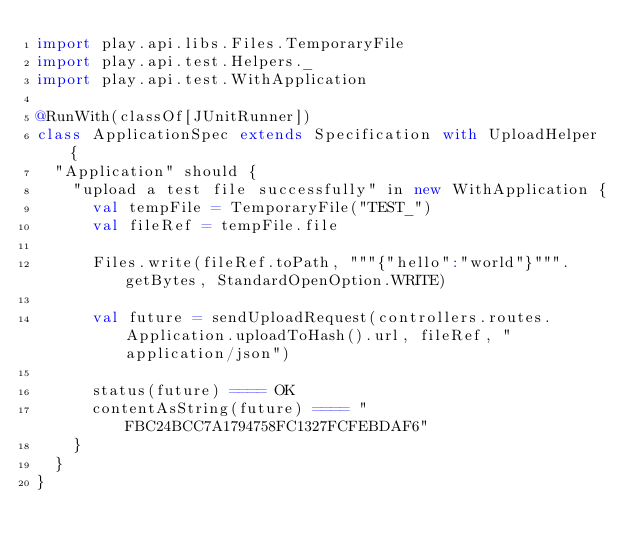Convert code to text. <code><loc_0><loc_0><loc_500><loc_500><_Scala_>import play.api.libs.Files.TemporaryFile
import play.api.test.Helpers._
import play.api.test.WithApplication

@RunWith(classOf[JUnitRunner])
class ApplicationSpec extends Specification with UploadHelper {
  "Application" should {
    "upload a test file successfully" in new WithApplication {
      val tempFile = TemporaryFile("TEST_")
      val fileRef = tempFile.file

      Files.write(fileRef.toPath, """{"hello":"world"}""".getBytes, StandardOpenOption.WRITE)

      val future = sendUploadRequest(controllers.routes.Application.uploadToHash().url, fileRef, "application/json")

      status(future) ==== OK
      contentAsString(future) ==== "FBC24BCC7A1794758FC1327FCFEBDAF6"
    }
  }
}
</code> 